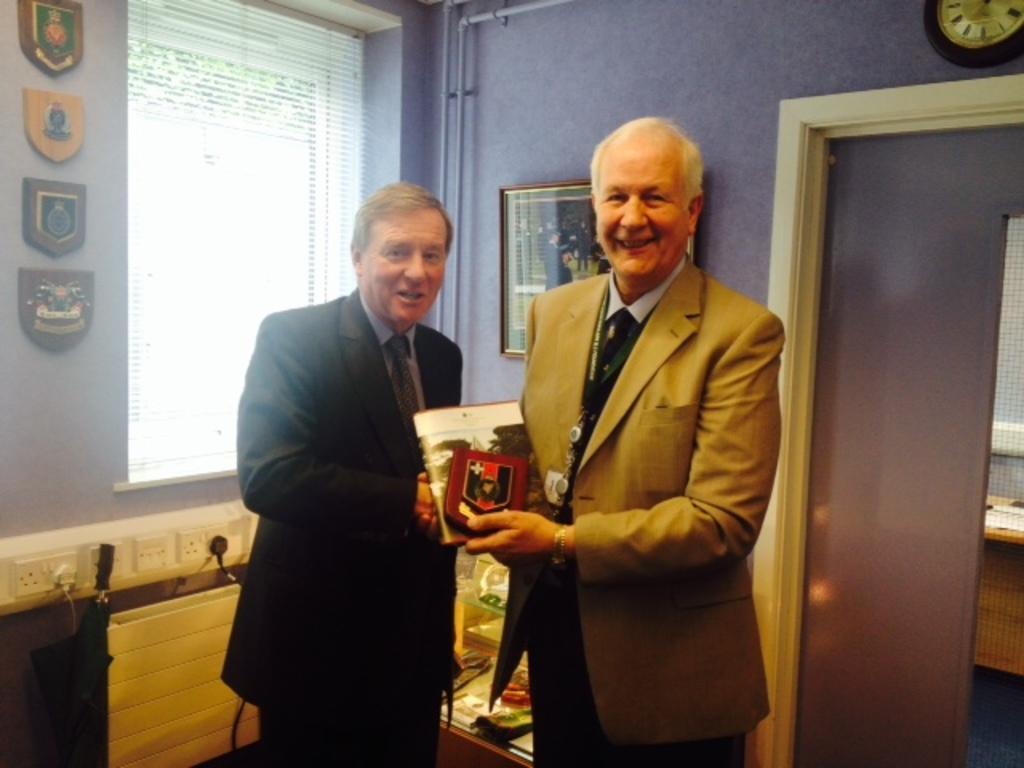How would you summarize this image in a sentence or two? This picture is clicked inside the room. In the center we can see the two persons standing, wearing suits, smiling and shaking their hands and we can see there are some objects. In the background we can see the wall, picture frame hanging on the wall and we can see the clock hanging on the wall and we can see some objects hanging on the wall and we can see the window blind, metal rods, wall sockets and a door and many other objects. 